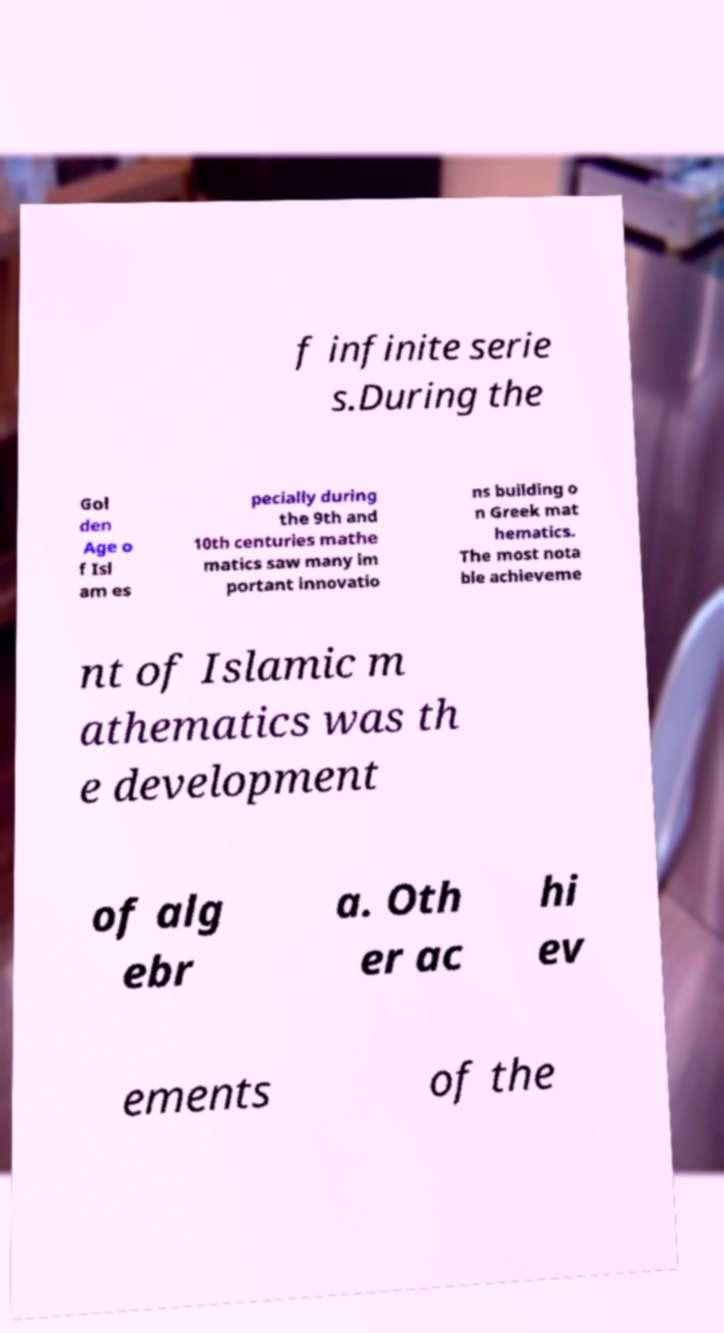What messages or text are displayed in this image? I need them in a readable, typed format. f infinite serie s.During the Gol den Age o f Isl am es pecially during the 9th and 10th centuries mathe matics saw many im portant innovatio ns building o n Greek mat hematics. The most nota ble achieveme nt of Islamic m athematics was th e development of alg ebr a. Oth er ac hi ev ements of the 